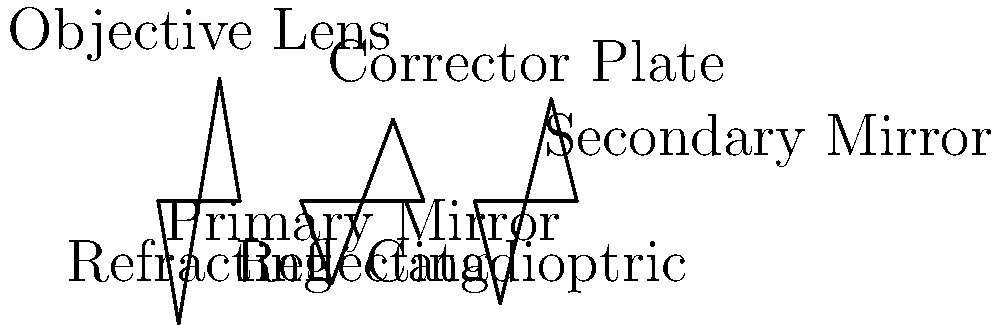Which type of telescope is best suited for observing faint, distant objects like galaxies, considering your limited energy due to chronic illness and the need for a telescope that requires less frequent adjustments? Let's consider each type of telescope and how it relates to your situation:

1. Refracting Telescope:
   - Uses lenses to gather and focus light
   - Generally smaller and more portable
   - Requires less maintenance
   - Limited in size due to lens sagging

2. Reflecting Telescope:
   - Uses mirrors to gather and focus light
   - Can be made much larger than refracting telescopes
   - Better at collecting light from faint, distant objects
   - Requires occasional realignment (collimation)

3. Catadioptric Telescope:
   - Combines lenses and mirrors
   - Compact design
   - Good for both planetary and deep-sky viewing
   - Requires less frequent adjustments than pure reflectors

Considering your chronic illness and the need for a telescope that requires less frequent adjustments, the best option for observing faint, distant objects like galaxies would be the Catadioptric telescope. Here's why:

1. It offers a good balance between light-gathering power and ease of use.
2. Its compact design makes it easier to handle with limited energy.
3. It requires less frequent adjustments compared to pure reflecting telescopes.
4. It provides good performance for observing both planets and deep-sky objects like galaxies.

While a large reflecting telescope might offer the best light-gathering power for faint objects, the maintenance and adjustment requirements could be challenging given your health condition. The Catadioptric telescope offers a good compromise between performance and ease of use.
Answer: Catadioptric telescope 